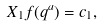<formula> <loc_0><loc_0><loc_500><loc_500>X _ { 1 } f ( q ^ { a } ) = c _ { 1 } ,</formula> 